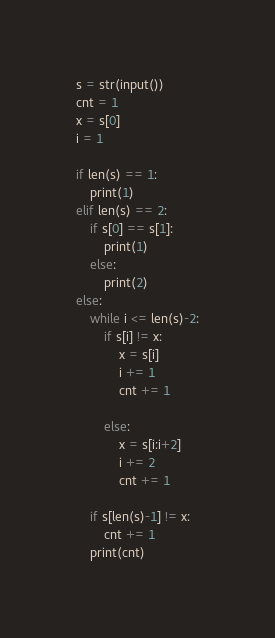Convert code to text. <code><loc_0><loc_0><loc_500><loc_500><_Python_>s = str(input())
cnt = 1
x = s[0]
i = 1

if len(s) == 1:
    print(1)
elif len(s) == 2:
    if s[0] == s[1]:
        print(1)
    else:
        print(2)
else:       
    while i <= len(s)-2:
        if s[i] != x:
            x = s[i]
            i += 1
            cnt += 1
         
        else:
            x = s[i:i+2]
            i += 2
            cnt += 1
           
    if s[len(s)-1] != x:
        cnt += 1
    print(cnt)
</code> 